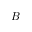<formula> <loc_0><loc_0><loc_500><loc_500>B</formula> 